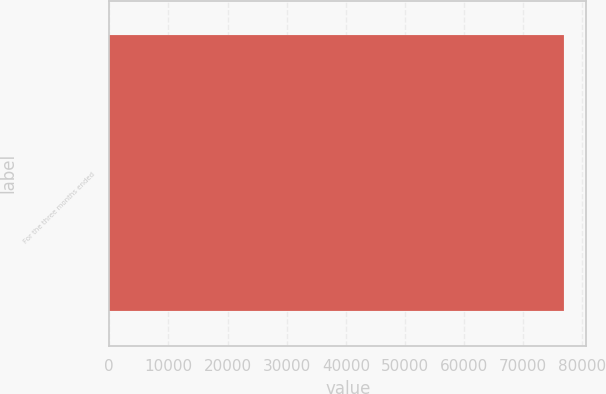<chart> <loc_0><loc_0><loc_500><loc_500><bar_chart><fcel>For the three months ended<nl><fcel>76845<nl></chart> 